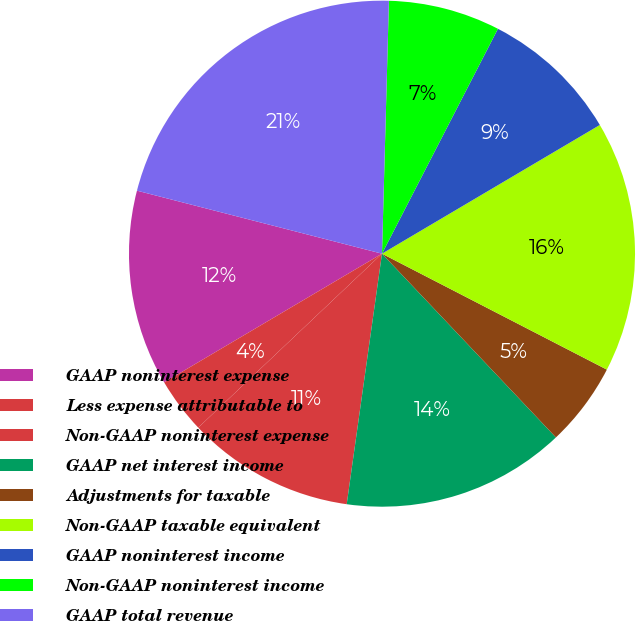Convert chart to OTSL. <chart><loc_0><loc_0><loc_500><loc_500><pie_chart><fcel>GAAP noninterest expense<fcel>Less expense attributable to<fcel>Non-GAAP noninterest expense<fcel>GAAP net interest income<fcel>Adjustments for taxable<fcel>Non-GAAP taxable equivalent<fcel>GAAP noninterest income<fcel>Non-GAAP noninterest income<fcel>GAAP total revenue<nl><fcel>12.5%<fcel>3.57%<fcel>10.71%<fcel>14.29%<fcel>5.36%<fcel>16.07%<fcel>8.93%<fcel>7.14%<fcel>21.43%<nl></chart> 